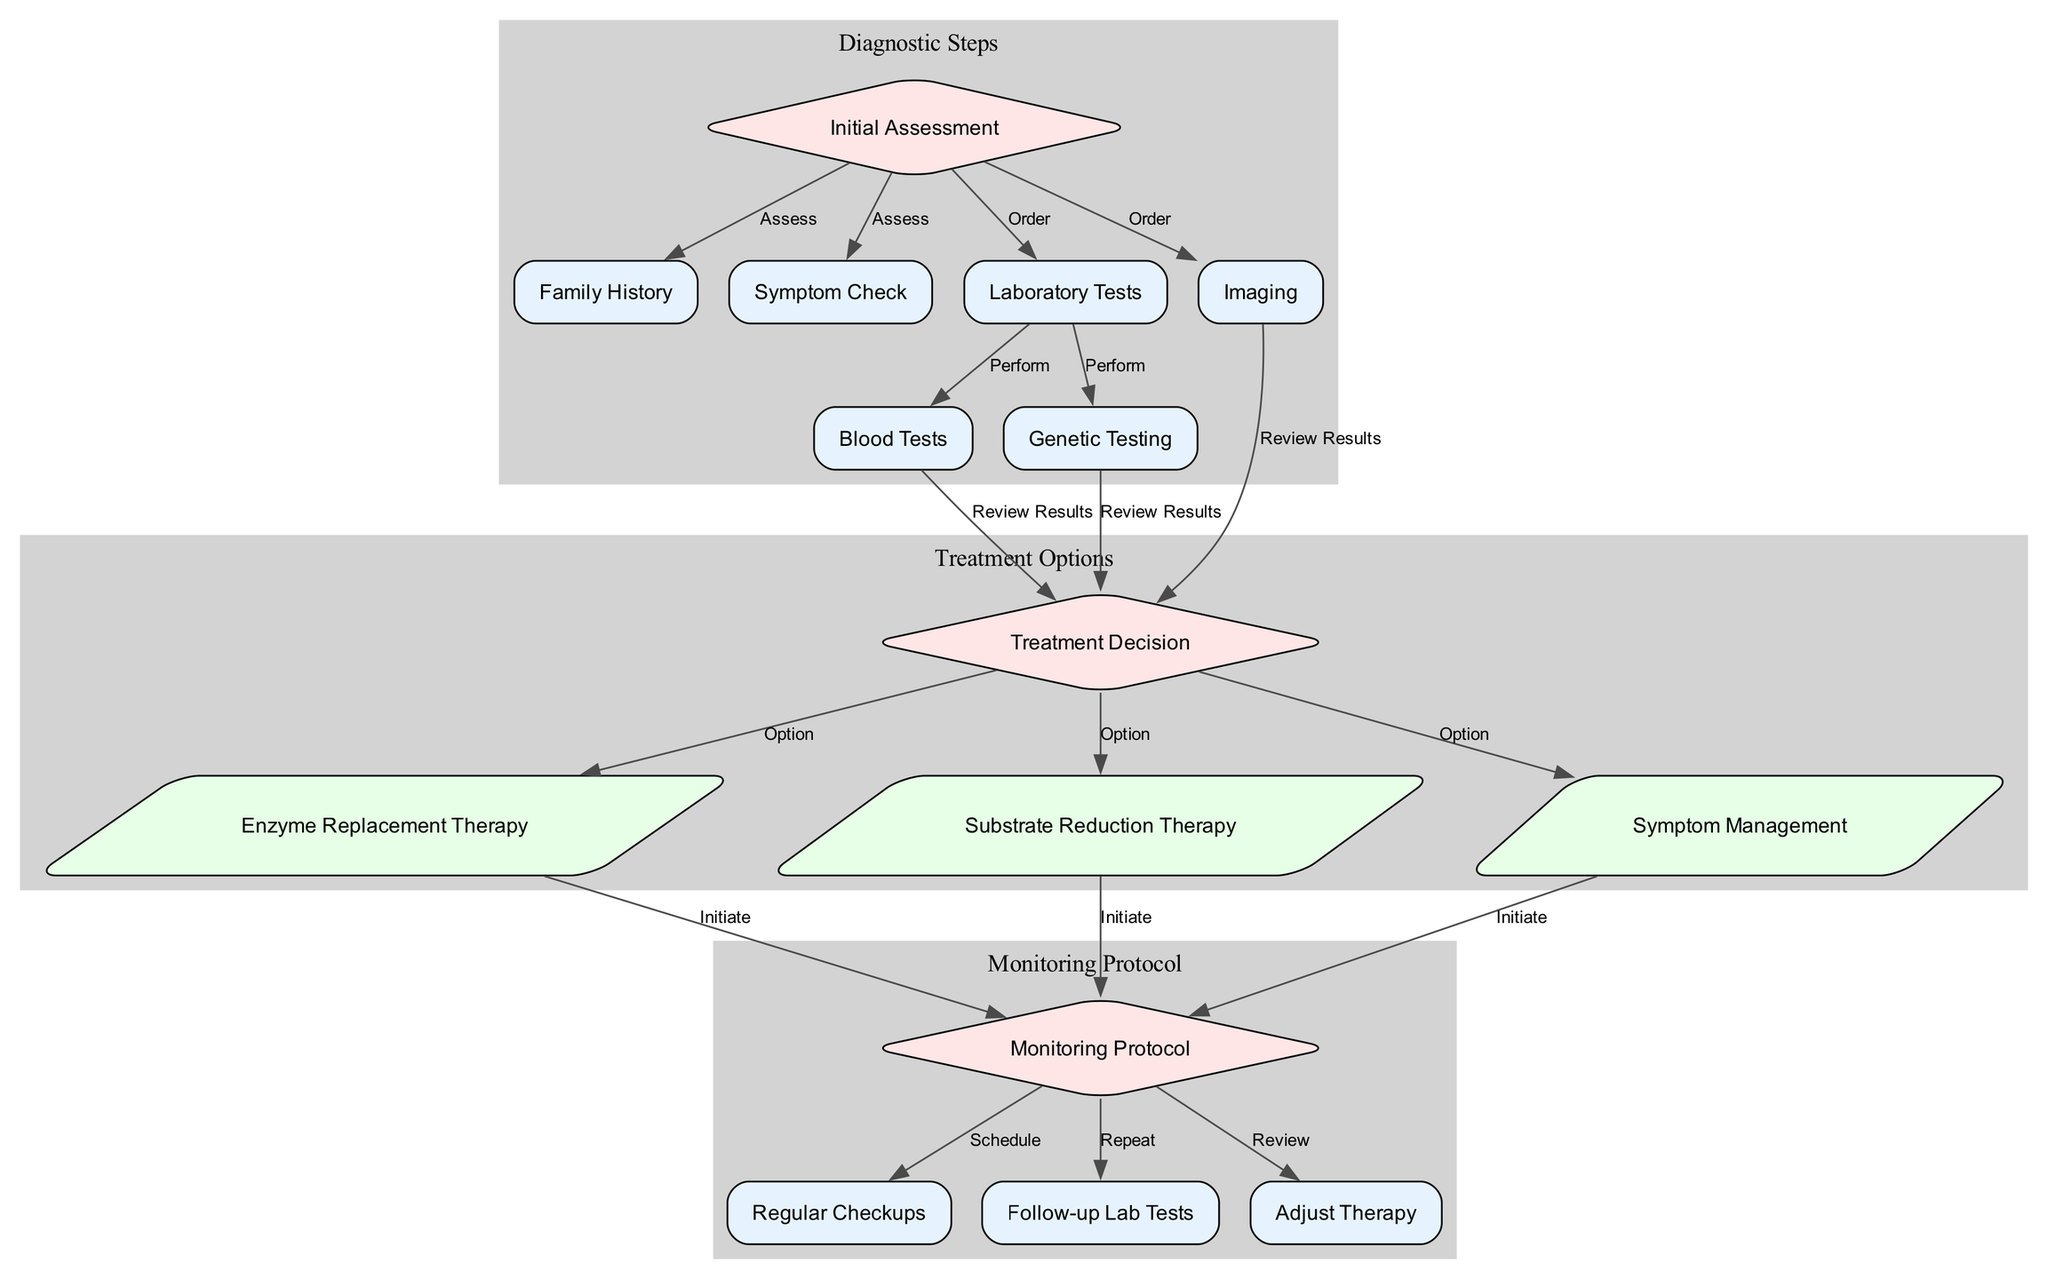what is the first step in the patient management workflow? The first step is 'Initial Assessment', as indicated at the beginning of the workflow. It is the starting point before any further assessments or tests are conducted.
Answer: Initial Assessment how many treatment options are presented in the diagram? The diagram shows three treatment options available after the treatment decision: Enzyme Replacement Therapy, Substrate Reduction Therapy, and Symptom Management. Therefore, the total number of treatment options is counted as three.
Answer: 3 which node follows 'Laboratory Tests' in the workflow? The nodes that follow 'Laboratory Tests' are 'Blood Tests' and 'Genetic Testing', which are both performed as a part of the laboratory testing phase according to the directed edges from 'Laboratory Tests'.
Answer: Blood Tests, Genetic Testing what happens after 'Imaging' is ordered? After 'Imaging' is ordered, the next action is to 'Review Results', which leads to the 'Treatment Decision' based on the imaging results provided. This flow of steps can be followed directly from the arrows leading from the 'Imaging' node.
Answer: Review Results how many nodes are there in total? The diagram contains a total of 15 nodes, including all diagnostic steps, treatment options, and monitoring protocols. This total can be counted from the node data provided.
Answer: 15 what is the last step in the monitoring protocol? The last step in the monitoring protocol is to 'Review' after the follow-up lab tests, which suggests adjusting therapy as necessary. This indicates a final assessment within the monitoring framework.
Answer: Review which treatment option is classified as a parallelogram? The treatment options that are classified as parallelograms in the diagram are 'Enzyme Replacement Therapy', 'Substrate Reduction Therapy', and 'Symptom Management', denoting their status as treatments.
Answer: Enzyme Replacement Therapy, Substrate Reduction Therapy, Symptom Management what connects 'Blood Tests' and 'Treatment Decision'? 'Blood Tests' is connected to 'Treatment Decision' by the edge labeled 'Review Results', indicating that results from blood tests need to be reviewed to inform treatment decisions. This direct relationship is indicated by the directed edge in the diagram.
Answer: Review Results 